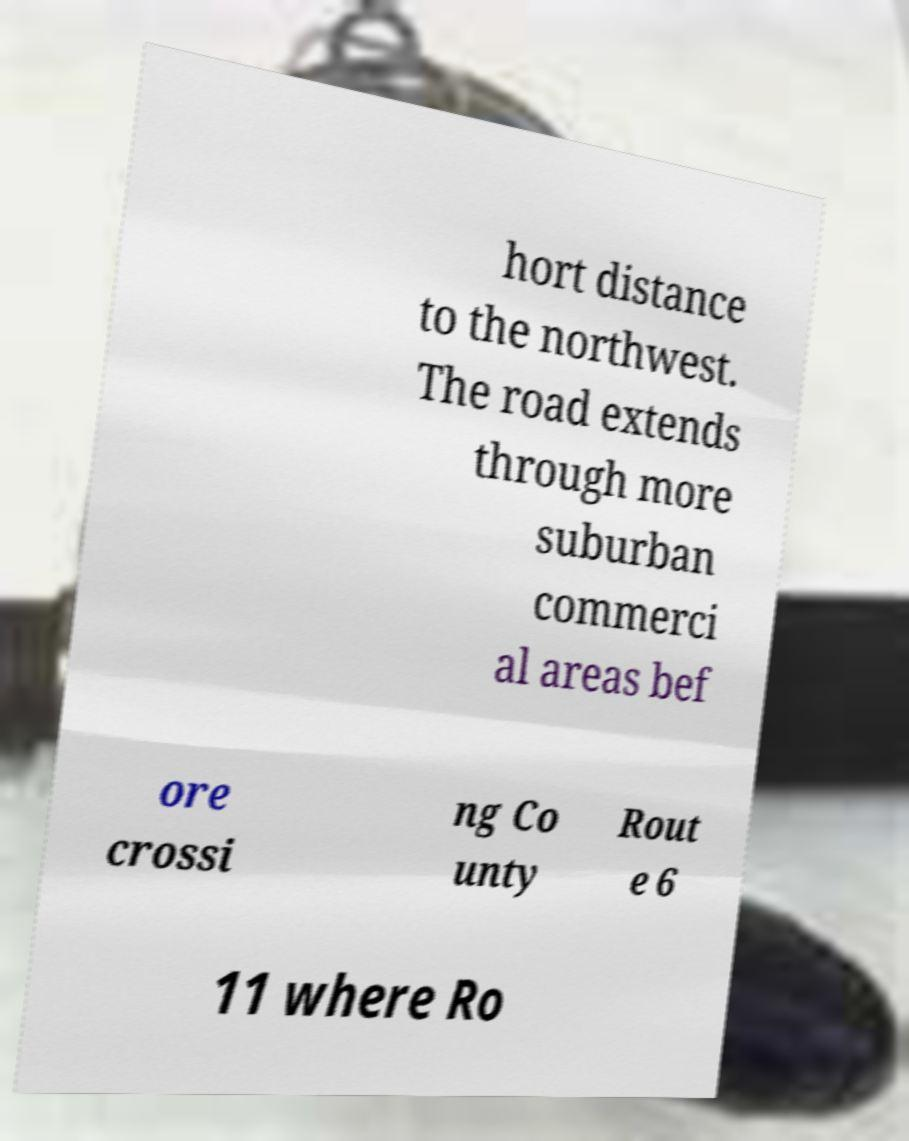Can you read and provide the text displayed in the image?This photo seems to have some interesting text. Can you extract and type it out for me? hort distance to the northwest. The road extends through more suburban commerci al areas bef ore crossi ng Co unty Rout e 6 11 where Ro 